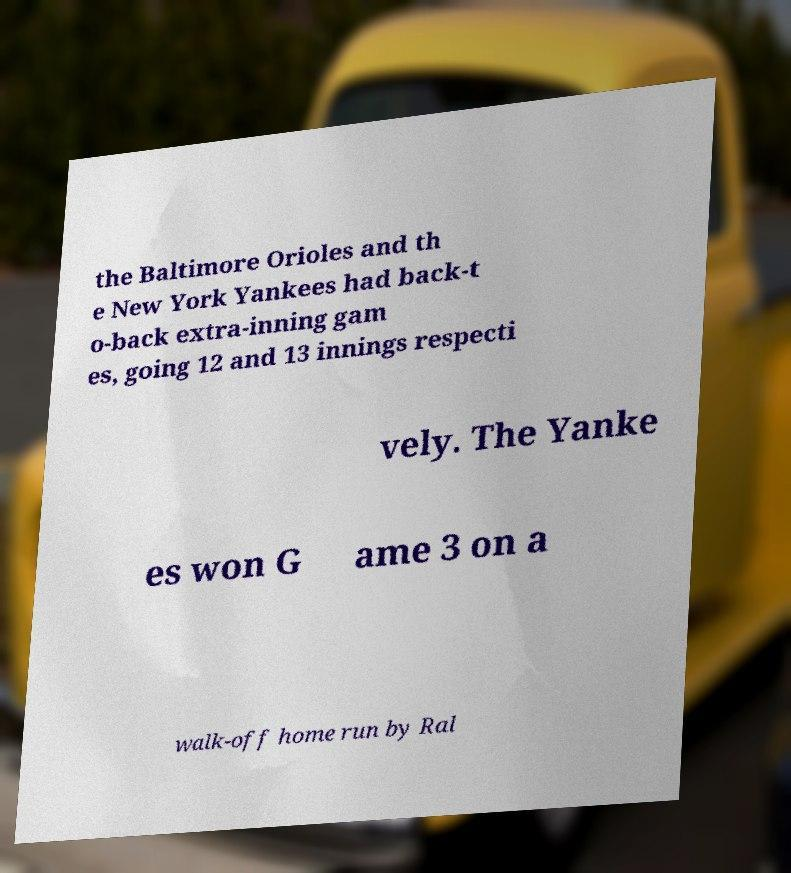There's text embedded in this image that I need extracted. Can you transcribe it verbatim? the Baltimore Orioles and th e New York Yankees had back-t o-back extra-inning gam es, going 12 and 13 innings respecti vely. The Yanke es won G ame 3 on a walk-off home run by Ral 